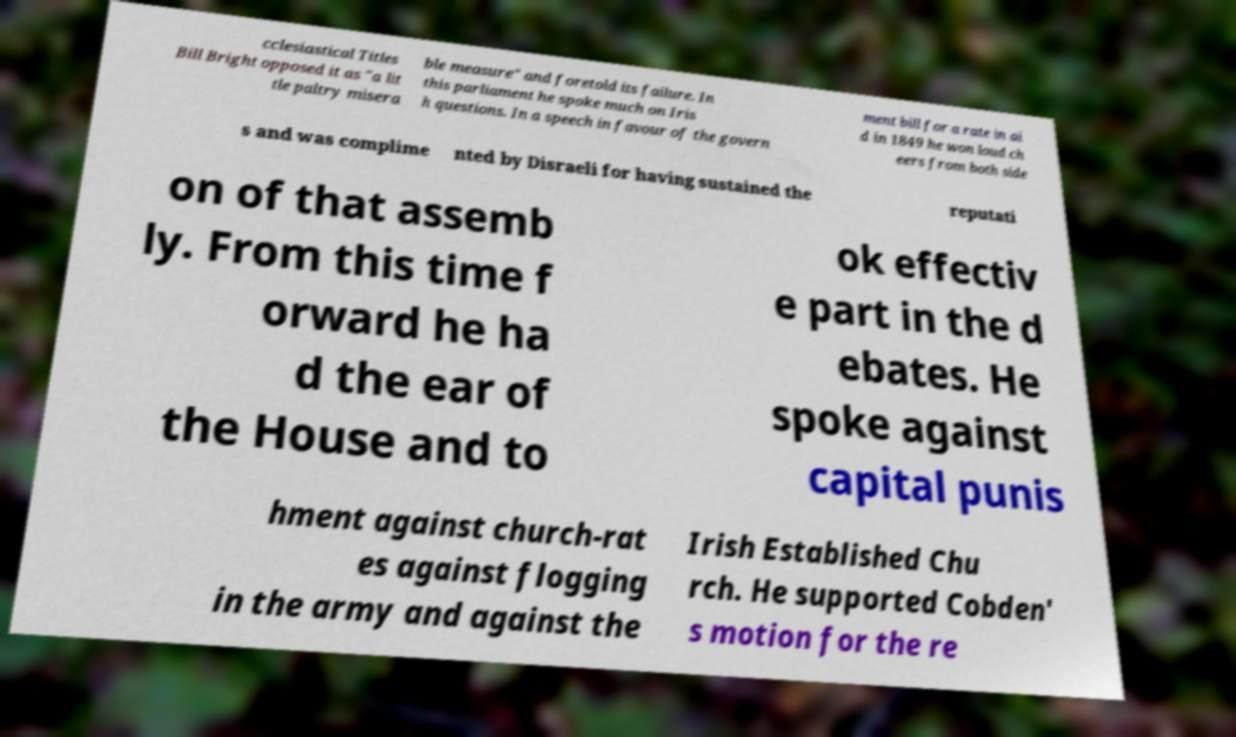Can you accurately transcribe the text from the provided image for me? cclesiastical Titles Bill Bright opposed it as "a lit tle paltry misera ble measure" and foretold its failure. In this parliament he spoke much on Iris h questions. In a speech in favour of the govern ment bill for a rate in ai d in 1849 he won loud ch eers from both side s and was complime nted by Disraeli for having sustained the reputati on of that assemb ly. From this time f orward he ha d the ear of the House and to ok effectiv e part in the d ebates. He spoke against capital punis hment against church-rat es against flogging in the army and against the Irish Established Chu rch. He supported Cobden' s motion for the re 